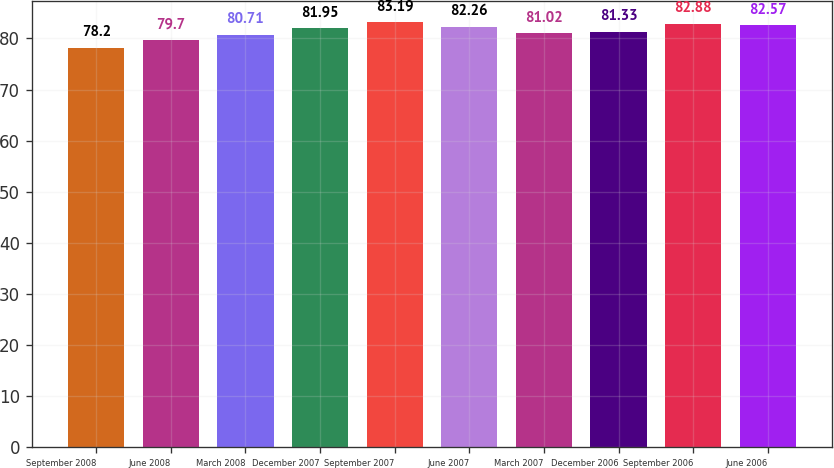Convert chart to OTSL. <chart><loc_0><loc_0><loc_500><loc_500><bar_chart><fcel>September 2008<fcel>June 2008<fcel>March 2008<fcel>December 2007<fcel>September 2007<fcel>June 2007<fcel>March 2007<fcel>December 2006<fcel>September 2006<fcel>June 2006<nl><fcel>78.2<fcel>79.7<fcel>80.71<fcel>81.95<fcel>83.19<fcel>82.26<fcel>81.02<fcel>81.33<fcel>82.88<fcel>82.57<nl></chart> 